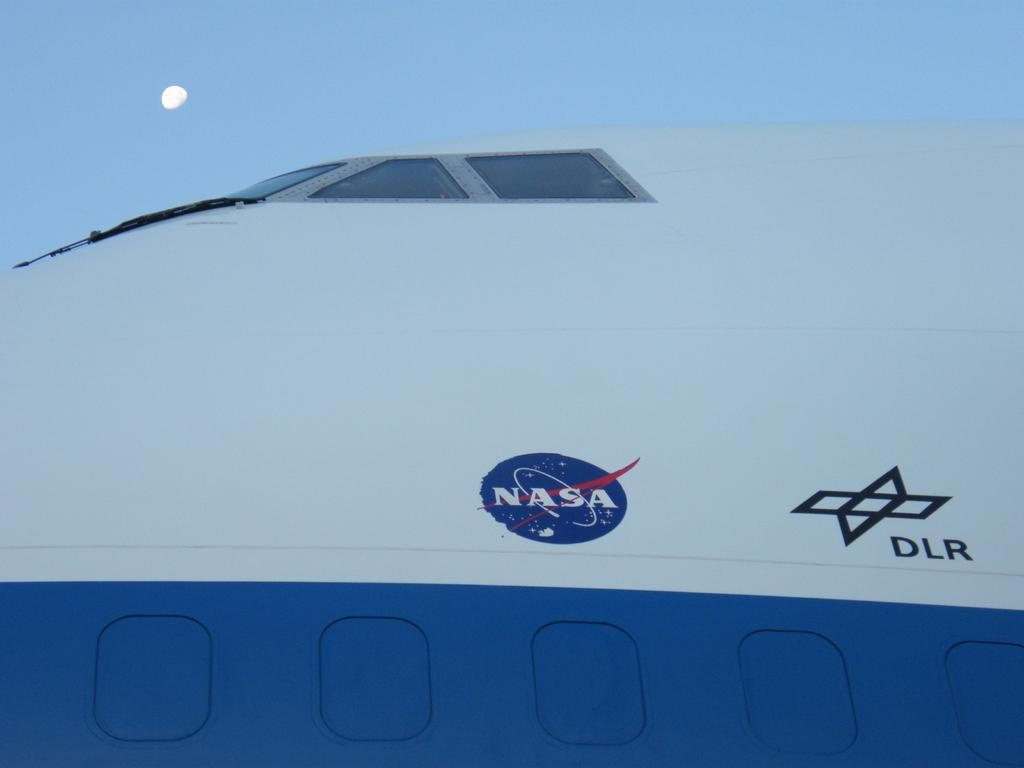<image>
Create a compact narrative representing the image presented. An upclose view of a NASA space shuttle. 